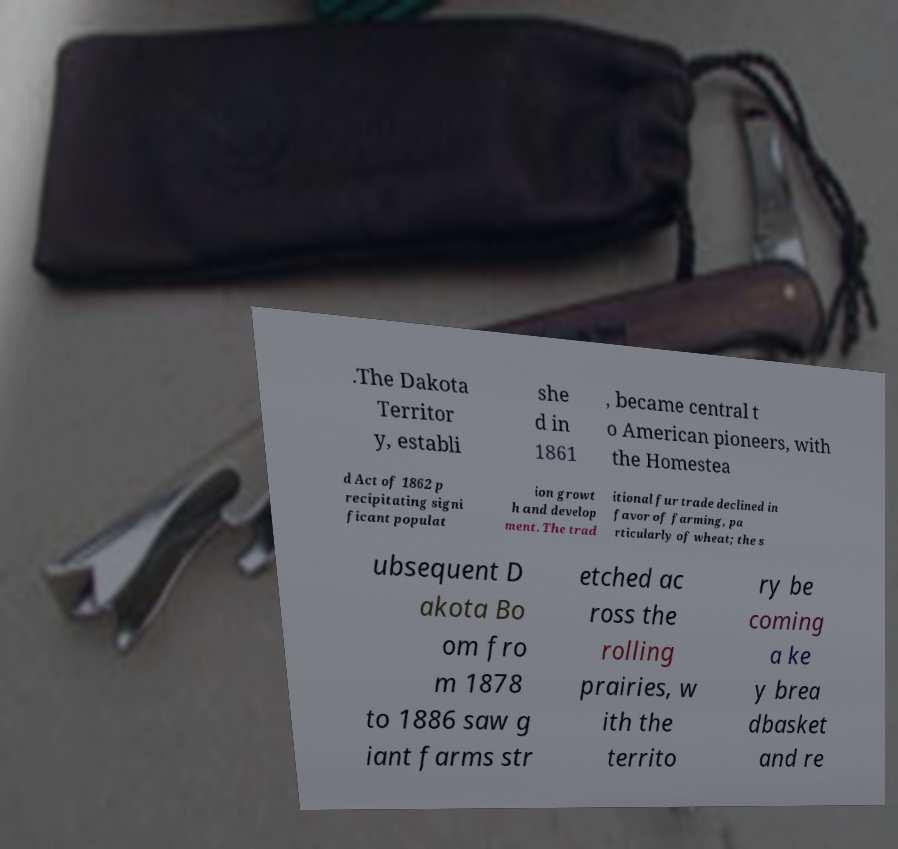Could you extract and type out the text from this image? .The Dakota Territor y, establi she d in 1861 , became central t o American pioneers, with the Homestea d Act of 1862 p recipitating signi ficant populat ion growt h and develop ment. The trad itional fur trade declined in favor of farming, pa rticularly of wheat; the s ubsequent D akota Bo om fro m 1878 to 1886 saw g iant farms str etched ac ross the rolling prairies, w ith the territo ry be coming a ke y brea dbasket and re 